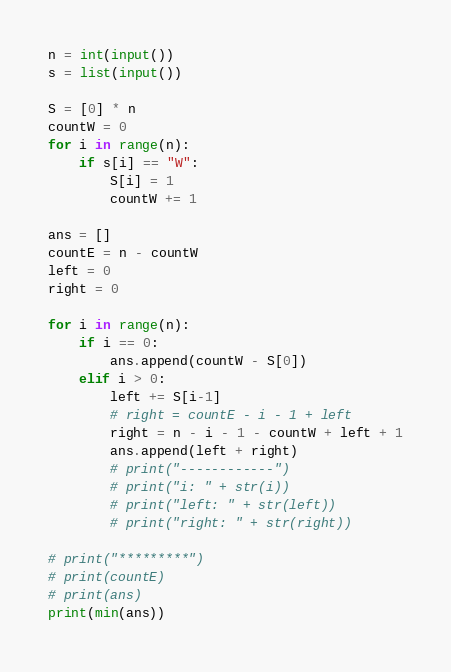Convert code to text. <code><loc_0><loc_0><loc_500><loc_500><_Python_>n = int(input())
s = list(input())

S = [0] * n
countW = 0
for i in range(n):
    if s[i] == "W":
        S[i] = 1
        countW += 1

ans = []
countE = n - countW
left = 0
right = 0

for i in range(n):
    if i == 0:
        ans.append(countW - S[0])
    elif i > 0:
        left += S[i-1]
        # right = countE - i - 1 + left
        right = n - i - 1 - countW + left + 1
        ans.append(left + right)
        # print("------------")
        # print("i: " + str(i))
        # print("left: " + str(left))
        # print("right: " + str(right))

# print("*********")
# print(countE)
# print(ans)
print(min(ans))</code> 